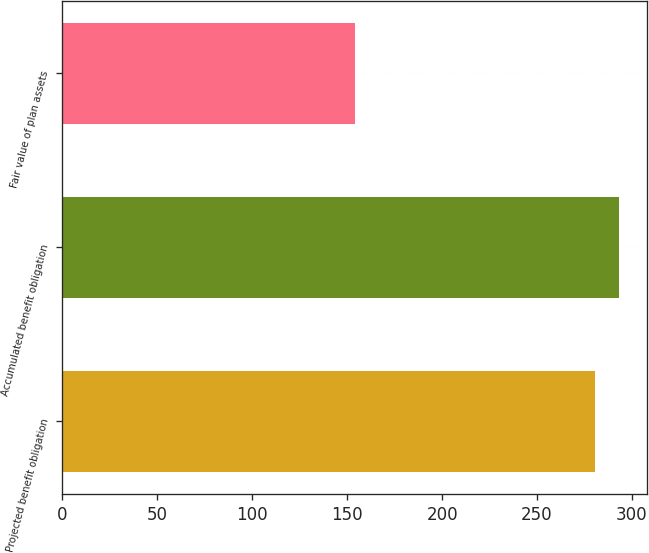Convert chart to OTSL. <chart><loc_0><loc_0><loc_500><loc_500><bar_chart><fcel>Projected benefit obligation<fcel>Accumulated benefit obligation<fcel>Fair value of plan assets<nl><fcel>280.3<fcel>293.1<fcel>154.2<nl></chart> 